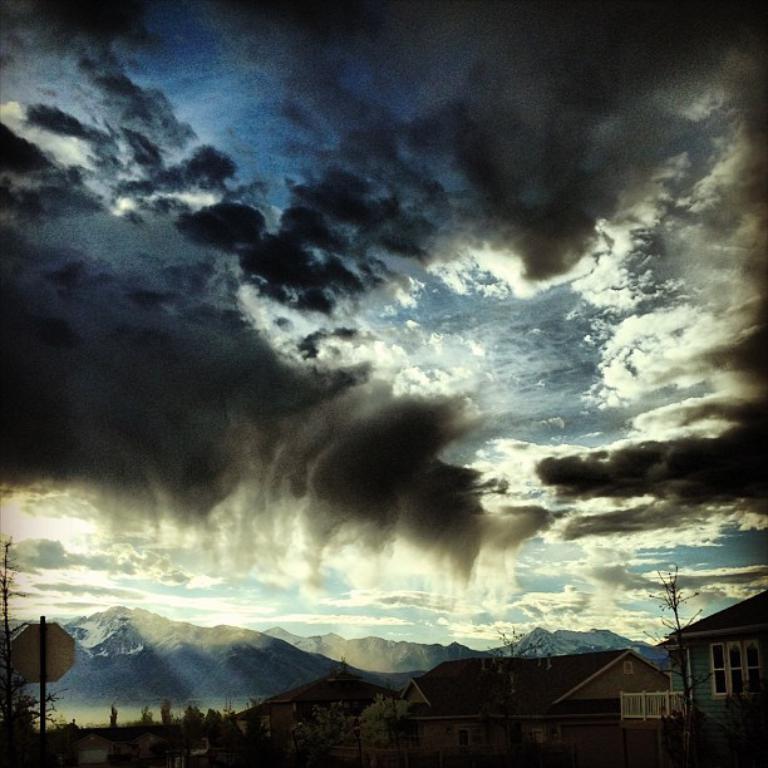In one or two sentences, can you explain what this image depicts? In this picture we can see sky and clouds. On the bottom right corner we can see two building. On the bottom we can see trees and plants. On the bottom left corner there is a sign board. In the background we can see mountains, snow and water. 